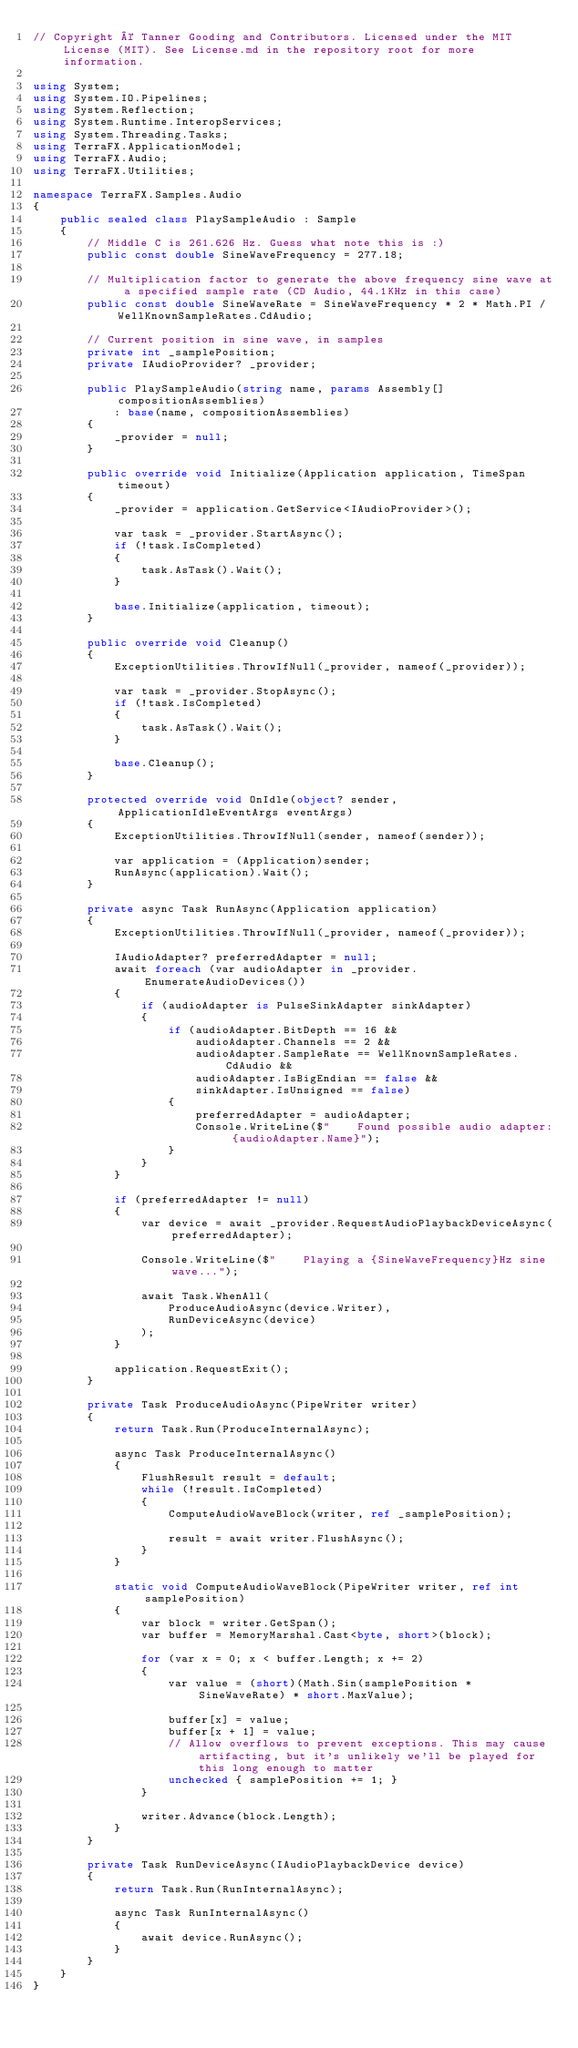<code> <loc_0><loc_0><loc_500><loc_500><_C#_>// Copyright © Tanner Gooding and Contributors. Licensed under the MIT License (MIT). See License.md in the repository root for more information.

using System;
using System.IO.Pipelines;
using System.Reflection;
using System.Runtime.InteropServices;
using System.Threading.Tasks;
using TerraFX.ApplicationModel;
using TerraFX.Audio;
using TerraFX.Utilities;

namespace TerraFX.Samples.Audio
{
    public sealed class PlaySampleAudio : Sample
    {
        // Middle C is 261.626 Hz. Guess what note this is :)
        public const double SineWaveFrequency = 277.18;

        // Multiplication factor to generate the above frequency sine wave at a specified sample rate (CD Audio, 44.1KHz in this case)
        public const double SineWaveRate = SineWaveFrequency * 2 * Math.PI / WellKnownSampleRates.CdAudio;

        // Current position in sine wave, in samples
        private int _samplePosition;
        private IAudioProvider? _provider;

        public PlaySampleAudio(string name, params Assembly[] compositionAssemblies)
            : base(name, compositionAssemblies)
        {
            _provider = null;
        }

        public override void Initialize(Application application, TimeSpan timeout)
        {
            _provider = application.GetService<IAudioProvider>();

            var task = _provider.StartAsync();
            if (!task.IsCompleted)
            {
                task.AsTask().Wait();
            }

            base.Initialize(application, timeout);
        }

        public override void Cleanup()
        {
            ExceptionUtilities.ThrowIfNull(_provider, nameof(_provider));

            var task = _provider.StopAsync();
            if (!task.IsCompleted)
            {
                task.AsTask().Wait();
            }

            base.Cleanup();
        }

        protected override void OnIdle(object? sender, ApplicationIdleEventArgs eventArgs)
        {
            ExceptionUtilities.ThrowIfNull(sender, nameof(sender));

            var application = (Application)sender;
            RunAsync(application).Wait();
        }

        private async Task RunAsync(Application application)
        {
            ExceptionUtilities.ThrowIfNull(_provider, nameof(_provider));

            IAudioAdapter? preferredAdapter = null;
            await foreach (var audioAdapter in _provider.EnumerateAudioDevices())
            {
                if (audioAdapter is PulseSinkAdapter sinkAdapter)
                {
                    if (audioAdapter.BitDepth == 16 &&
                        audioAdapter.Channels == 2 &&
                        audioAdapter.SampleRate == WellKnownSampleRates.CdAudio &&
                        audioAdapter.IsBigEndian == false &&
                        sinkAdapter.IsUnsigned == false)
                    {
                        preferredAdapter = audioAdapter;
                        Console.WriteLine($"    Found possible audio adapter: {audioAdapter.Name}");
                    }
                }
            }

            if (preferredAdapter != null)
            {
                var device = await _provider.RequestAudioPlaybackDeviceAsync(preferredAdapter);

                Console.WriteLine($"    Playing a {SineWaveFrequency}Hz sine wave...");

                await Task.WhenAll(
                    ProduceAudioAsync(device.Writer),
                    RunDeviceAsync(device)
                );
            }

            application.RequestExit();
        }

        private Task ProduceAudioAsync(PipeWriter writer)
        {
            return Task.Run(ProduceInternalAsync);

            async Task ProduceInternalAsync()
            {
                FlushResult result = default;
                while (!result.IsCompleted)
                {
                    ComputeAudioWaveBlock(writer, ref _samplePosition);

                    result = await writer.FlushAsync();
                }
            }

            static void ComputeAudioWaveBlock(PipeWriter writer, ref int samplePosition)
            {
                var block = writer.GetSpan();
                var buffer = MemoryMarshal.Cast<byte, short>(block);

                for (var x = 0; x < buffer.Length; x += 2)
                {
                    var value = (short)(Math.Sin(samplePosition * SineWaveRate) * short.MaxValue);

                    buffer[x] = value;
                    buffer[x + 1] = value;
                    // Allow overflows to prevent exceptions. This may cause artifacting, but it's unlikely we'll be played for this long enough to matter
                    unchecked { samplePosition += 1; }
                }

                writer.Advance(block.Length);
            }
        }

        private Task RunDeviceAsync(IAudioPlaybackDevice device)
        {
            return Task.Run(RunInternalAsync);

            async Task RunInternalAsync()
            {
                await device.RunAsync();
            }
        }
    }
}
</code> 